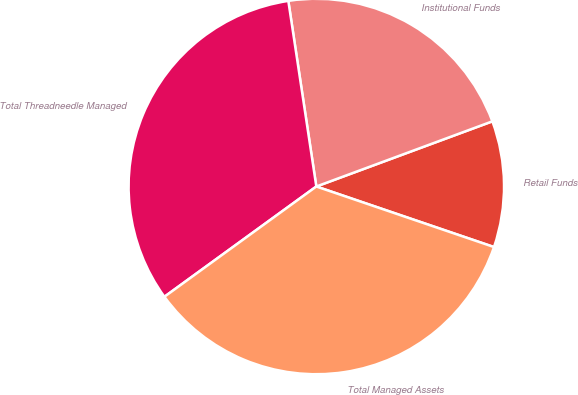Convert chart to OTSL. <chart><loc_0><loc_0><loc_500><loc_500><pie_chart><fcel>Retail Funds<fcel>Institutional Funds<fcel>Total Threadneedle Managed<fcel>Total Managed Assets<nl><fcel>10.87%<fcel>21.74%<fcel>32.61%<fcel>34.78%<nl></chart> 